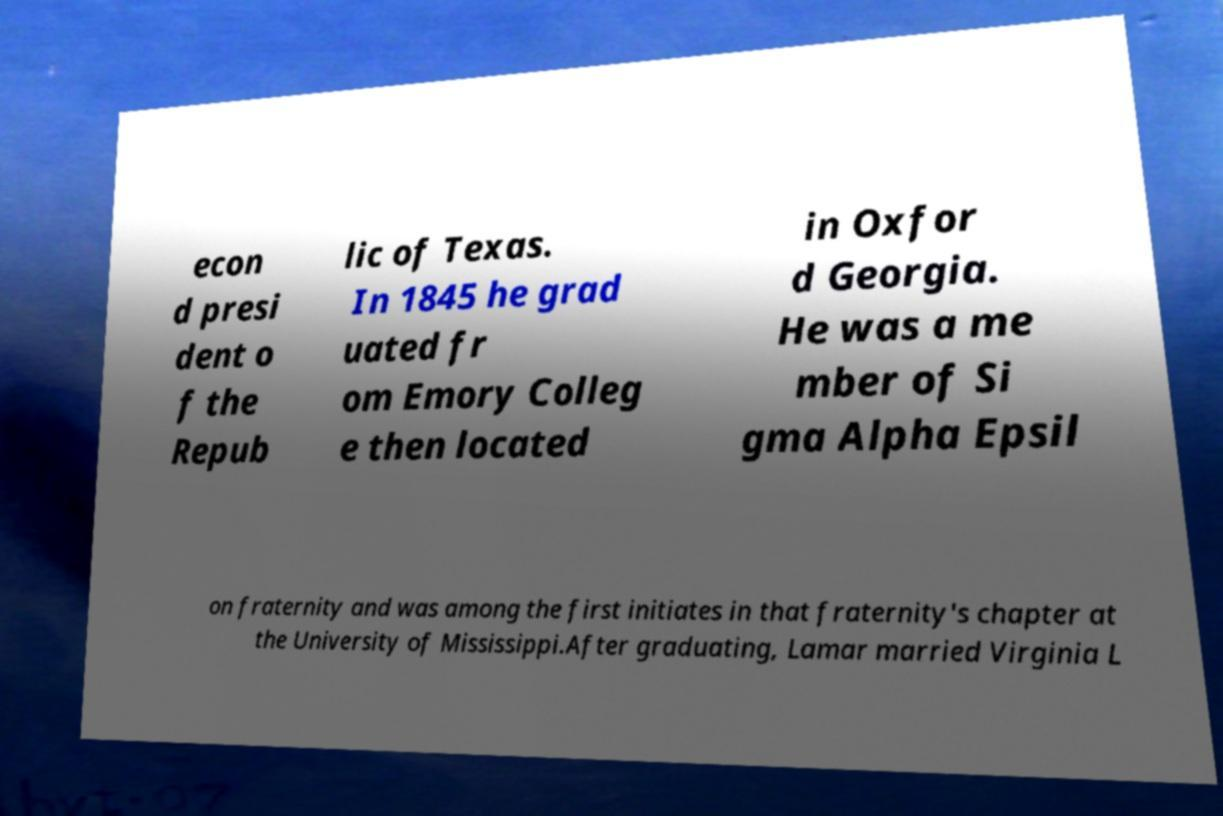Could you assist in decoding the text presented in this image and type it out clearly? econ d presi dent o f the Repub lic of Texas. In 1845 he grad uated fr om Emory Colleg e then located in Oxfor d Georgia. He was a me mber of Si gma Alpha Epsil on fraternity and was among the first initiates in that fraternity's chapter at the University of Mississippi.After graduating, Lamar married Virginia L 